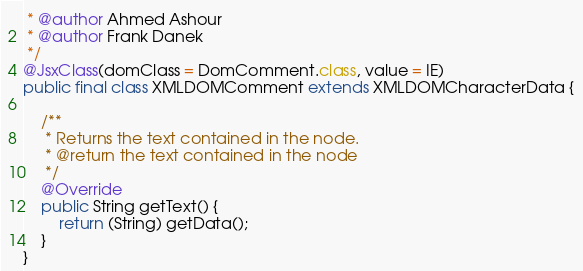<code> <loc_0><loc_0><loc_500><loc_500><_Java_> * @author Ahmed Ashour
 * @author Frank Danek
 */
@JsxClass(domClass = DomComment.class, value = IE)
public final class XMLDOMComment extends XMLDOMCharacterData {

    /**
     * Returns the text contained in the node.
     * @return the text contained in the node
     */
    @Override
    public String getText() {
        return (String) getData();
    }
}
</code> 